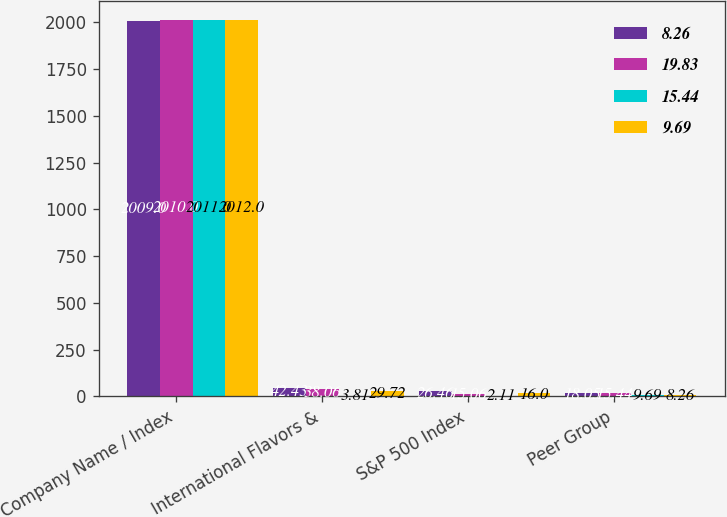Convert chart to OTSL. <chart><loc_0><loc_0><loc_500><loc_500><stacked_bar_chart><ecel><fcel>Company Name / Index<fcel>International Flavors &<fcel>S&P 500 Index<fcel>Peer Group<nl><fcel>8.26<fcel>2009<fcel>42.43<fcel>26.46<fcel>18.05<nl><fcel>19.83<fcel>2010<fcel>38.06<fcel>15.06<fcel>15.44<nl><fcel>15.44<fcel>2011<fcel>3.81<fcel>2.11<fcel>9.69<nl><fcel>9.69<fcel>2012<fcel>29.72<fcel>16<fcel>8.26<nl></chart> 